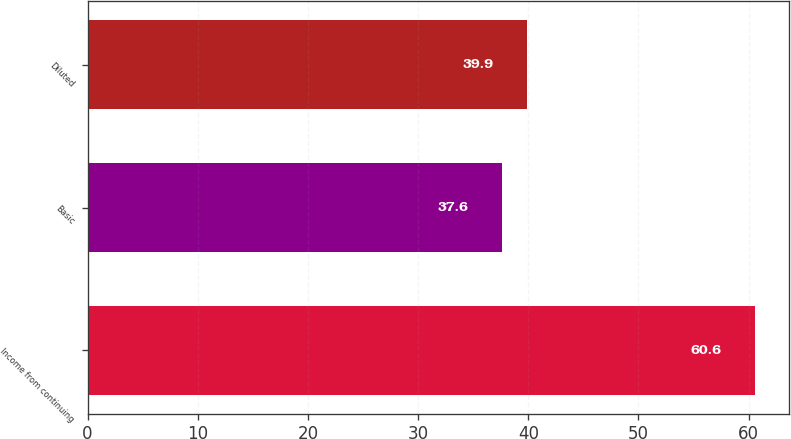Convert chart. <chart><loc_0><loc_0><loc_500><loc_500><bar_chart><fcel>Income from continuing<fcel>Basic<fcel>Diluted<nl><fcel>60.6<fcel>37.6<fcel>39.9<nl></chart> 